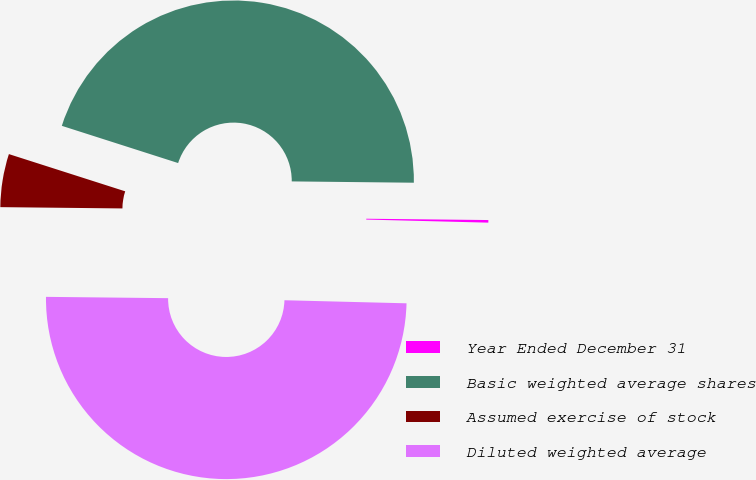Convert chart. <chart><loc_0><loc_0><loc_500><loc_500><pie_chart><fcel>Year Ended December 31<fcel>Basic weighted average shares<fcel>Assumed exercise of stock<fcel>Diluted weighted average<nl><fcel>0.23%<fcel>45.24%<fcel>4.76%<fcel>49.77%<nl></chart> 